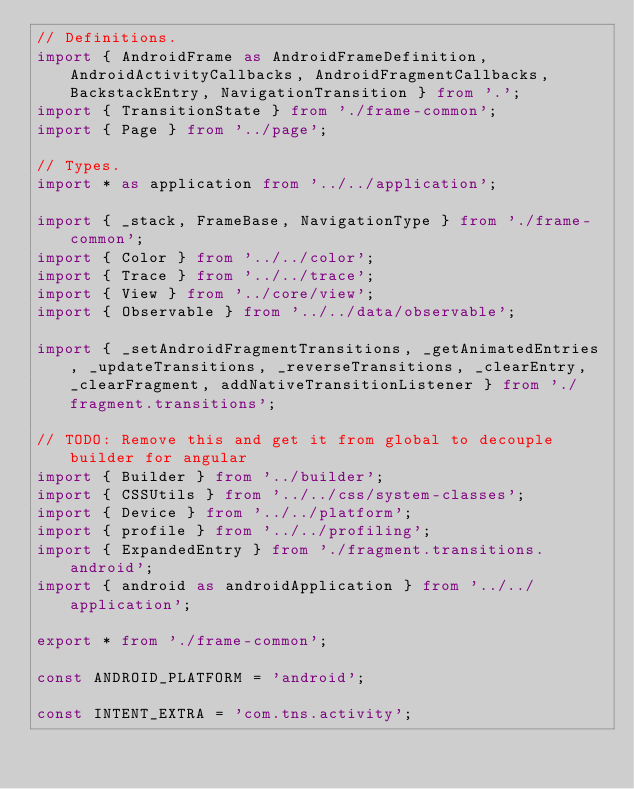Convert code to text. <code><loc_0><loc_0><loc_500><loc_500><_TypeScript_>// Definitions.
import { AndroidFrame as AndroidFrameDefinition, AndroidActivityCallbacks, AndroidFragmentCallbacks, BackstackEntry, NavigationTransition } from '.';
import { TransitionState } from './frame-common';
import { Page } from '../page';

// Types.
import * as application from '../../application';

import { _stack, FrameBase, NavigationType } from './frame-common';
import { Color } from '../../color';
import { Trace } from '../../trace';
import { View } from '../core/view';
import { Observable } from '../../data/observable';

import { _setAndroidFragmentTransitions, _getAnimatedEntries, _updateTransitions, _reverseTransitions, _clearEntry, _clearFragment, addNativeTransitionListener } from './fragment.transitions';

// TODO: Remove this and get it from global to decouple builder for angular
import { Builder } from '../builder';
import { CSSUtils } from '../../css/system-classes';
import { Device } from '../../platform';
import { profile } from '../../profiling';
import { ExpandedEntry } from './fragment.transitions.android';
import { android as androidApplication } from '../../application';

export * from './frame-common';

const ANDROID_PLATFORM = 'android';

const INTENT_EXTRA = 'com.tns.activity';</code> 